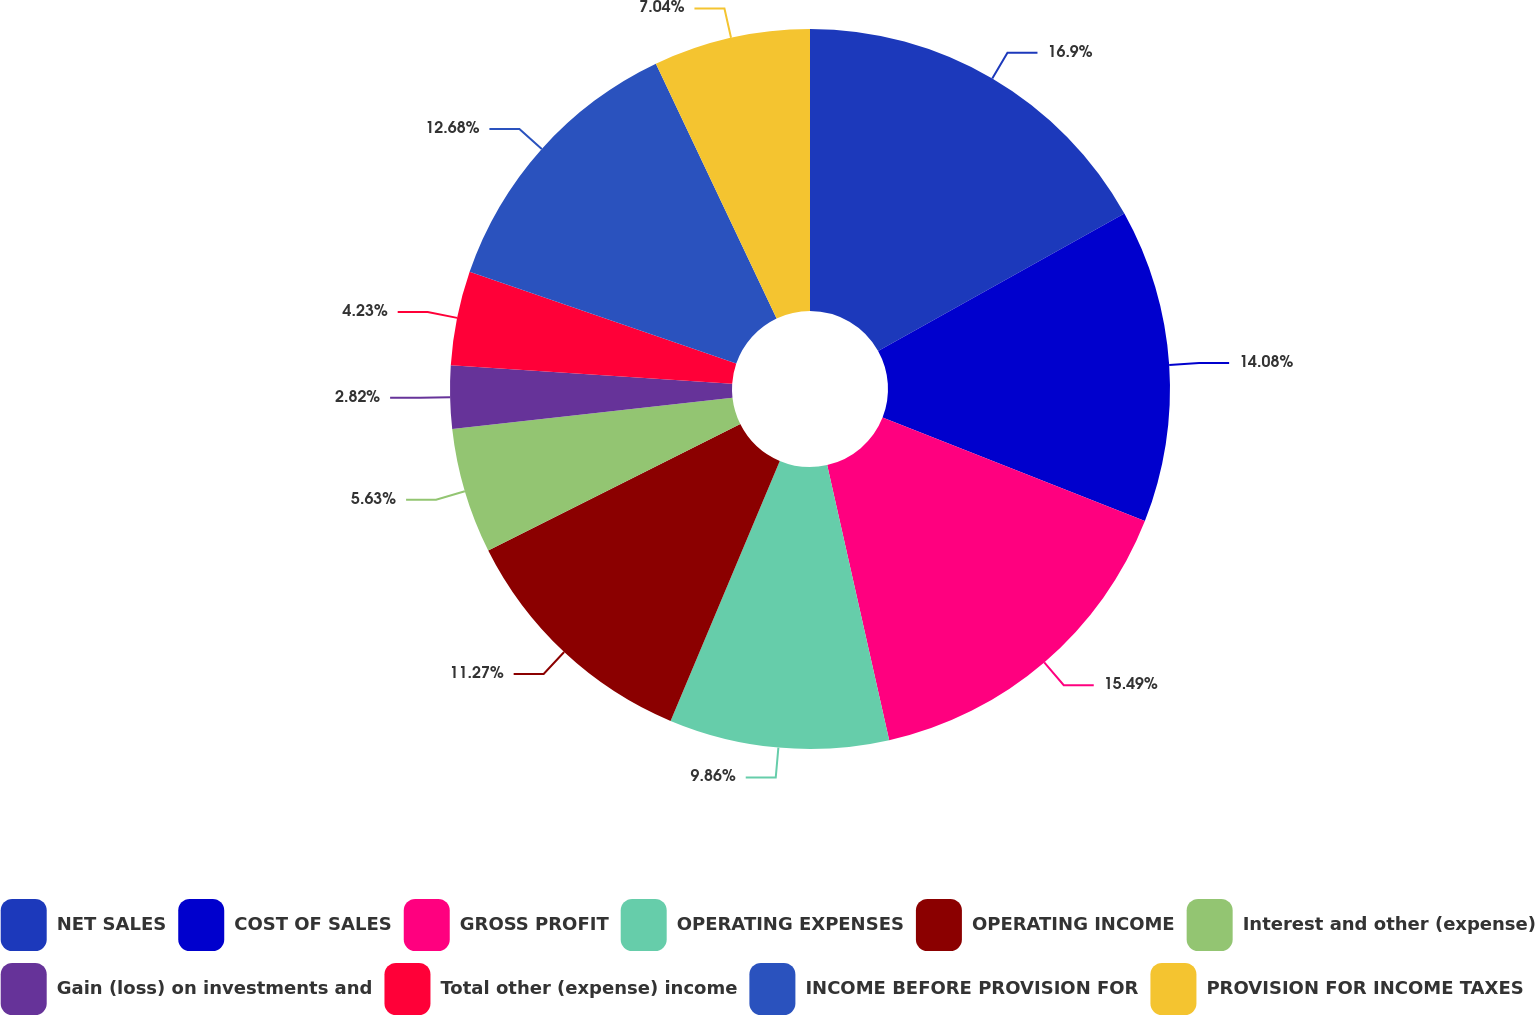Convert chart to OTSL. <chart><loc_0><loc_0><loc_500><loc_500><pie_chart><fcel>NET SALES<fcel>COST OF SALES<fcel>GROSS PROFIT<fcel>OPERATING EXPENSES<fcel>OPERATING INCOME<fcel>Interest and other (expense)<fcel>Gain (loss) on investments and<fcel>Total other (expense) income<fcel>INCOME BEFORE PROVISION FOR<fcel>PROVISION FOR INCOME TAXES<nl><fcel>16.9%<fcel>14.08%<fcel>15.49%<fcel>9.86%<fcel>11.27%<fcel>5.63%<fcel>2.82%<fcel>4.23%<fcel>12.68%<fcel>7.04%<nl></chart> 